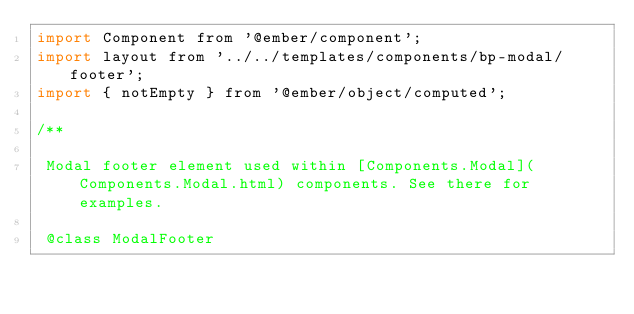Convert code to text. <code><loc_0><loc_0><loc_500><loc_500><_JavaScript_>import Component from '@ember/component';
import layout from '../../templates/components/bp-modal/footer';
import { notEmpty } from '@ember/object/computed';

/**

 Modal footer element used within [Components.Modal](Components.Modal.html) components. See there for examples.

 @class ModalFooter</code> 